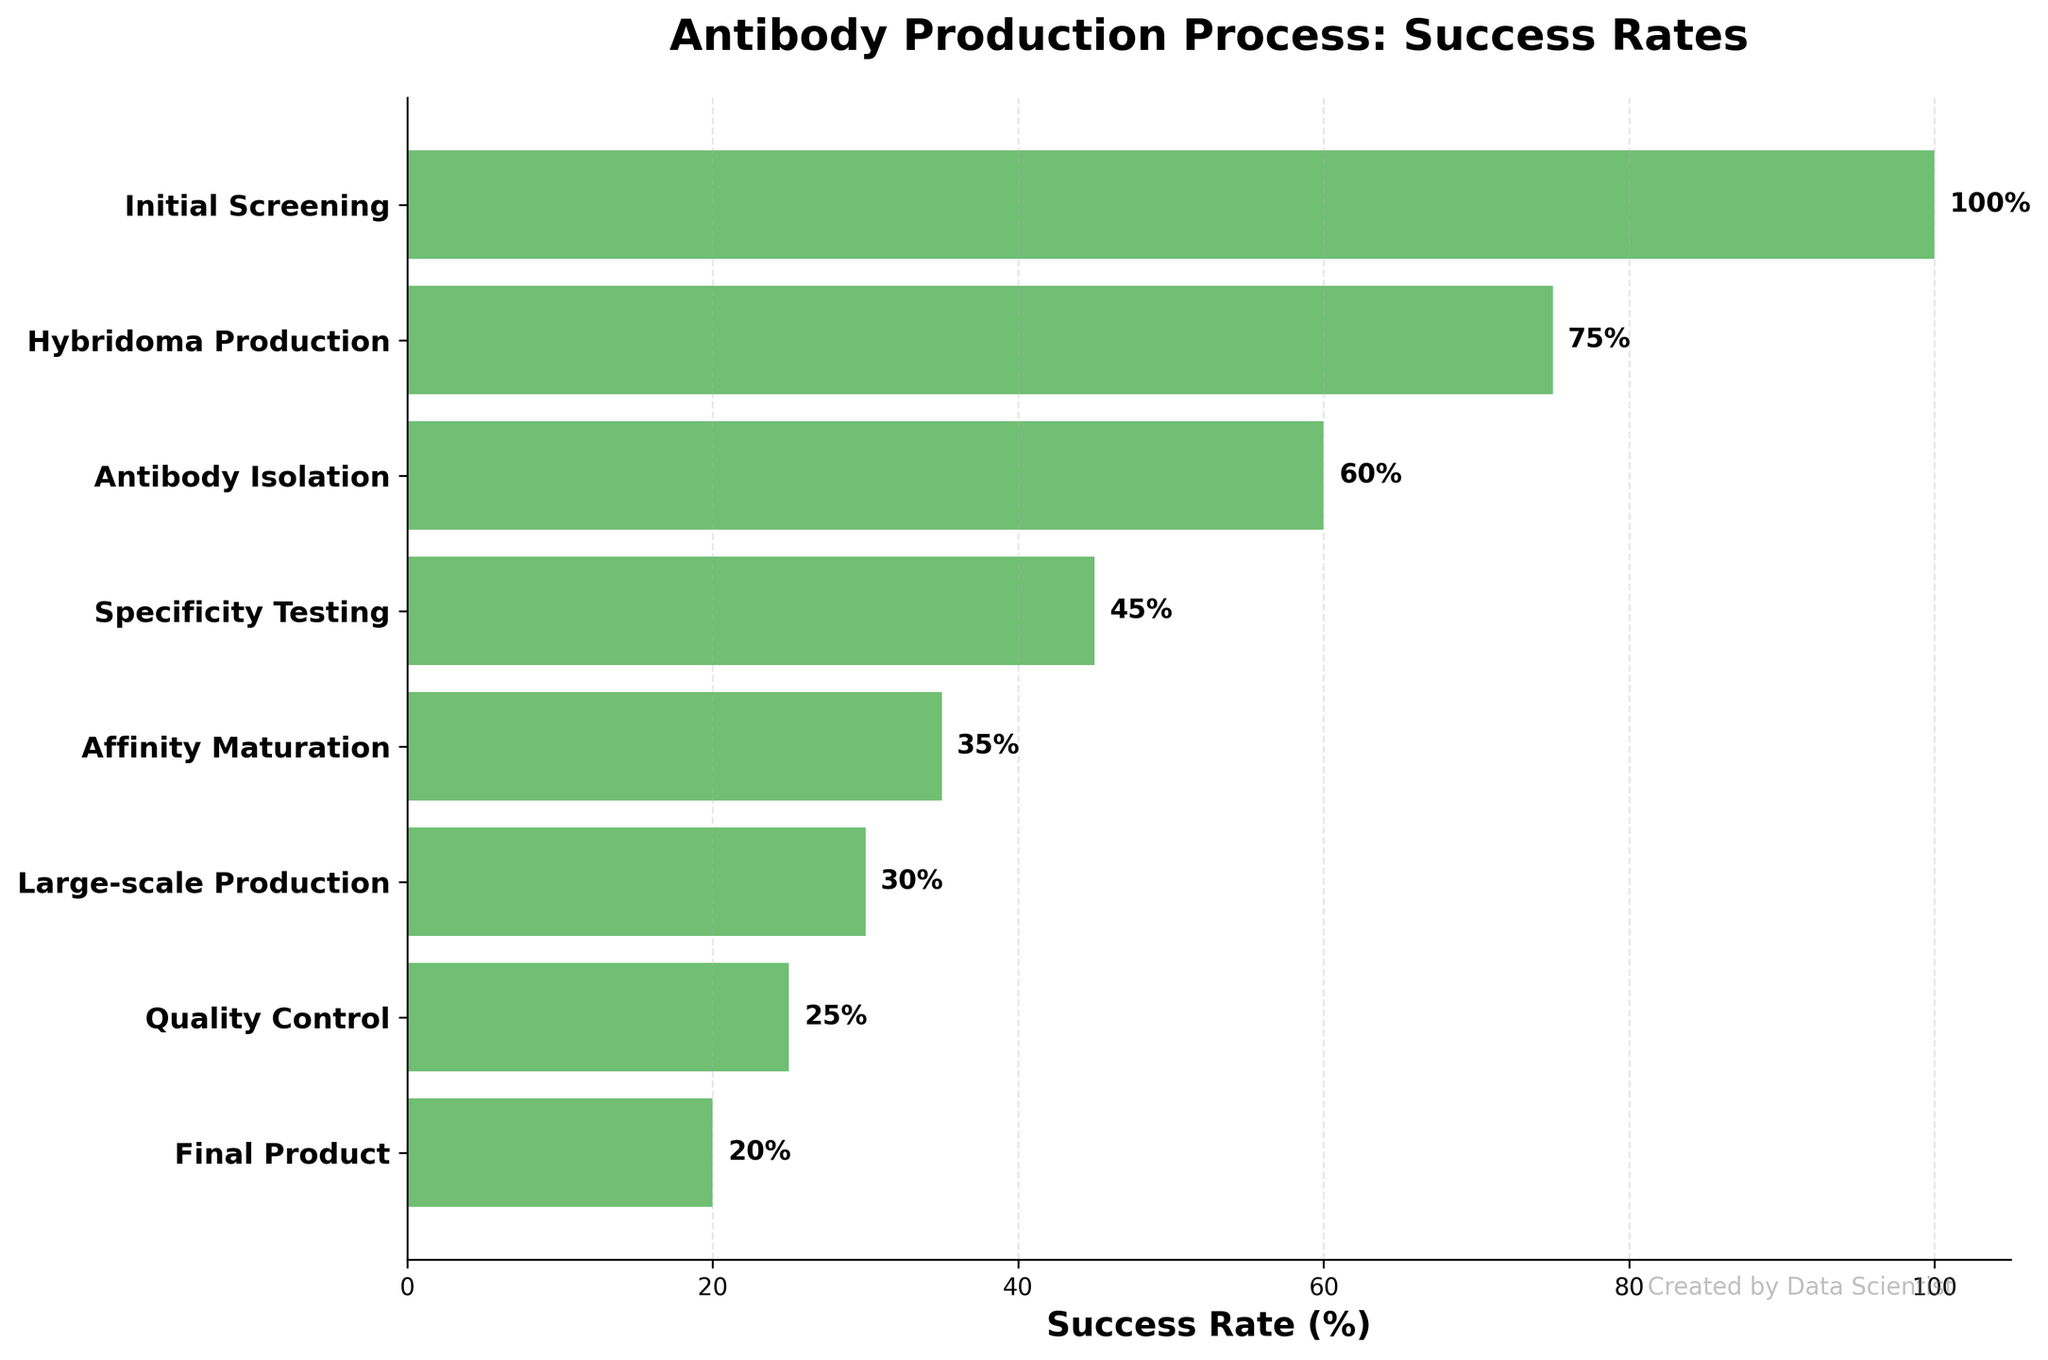How many stages are depicted in the funnel chart? Count the total number of stages listed on the y-axis of the figure.
Answer: 8 What is the title of the funnel chart? Look at the top of the figure where the title is usually located.
Answer: Antibody Production Process: Success Rates Which stage has the highest success rate? Identify the stage with the largest bar length on the x-axis.
Answer: Initial Screening Which stage has the lowest success rate? Identify the stage with the smallest bar length on the x-axis.
Answer: Final Product What is the difference in success rate between Hybridoma Production and Affinity Maturation? Subtract the success rate of Affinity Maturation from Hybridoma Production (75% - 35%).
Answer: 40% What is the average success rate of the stages? Sum all the success rates and divide by the number of stages (100 + 75 + 60 + 45 + 35 + 30 + 25 + 20) / 8.
Answer: 48.75% Compared to Specificity Testing, which stage has a higher success rate, and by how much? Hybridoma Production has a higher success rate compared to Specificity Testing. Subtract the success rate of Specificity Testing from Hybridoma Production (75% - 45%).
Answer: 30% Between Antibody Isolation and Large-scale Production, which stage has a greater drop in success rate from the previous stage? Calculate the drop between Initial Screening and Antibody Isolation (100% - 60%) and compare it with the drop between Affinity Maturation and Large-scale Production (35% - 30%).
Answer: Antibody Isolation What is the total decrease in success rate from Initial Screening to Final Product? Subtract the success rate of the Final Product from Initial Screening (100% - 20%).
Answer: 80% 